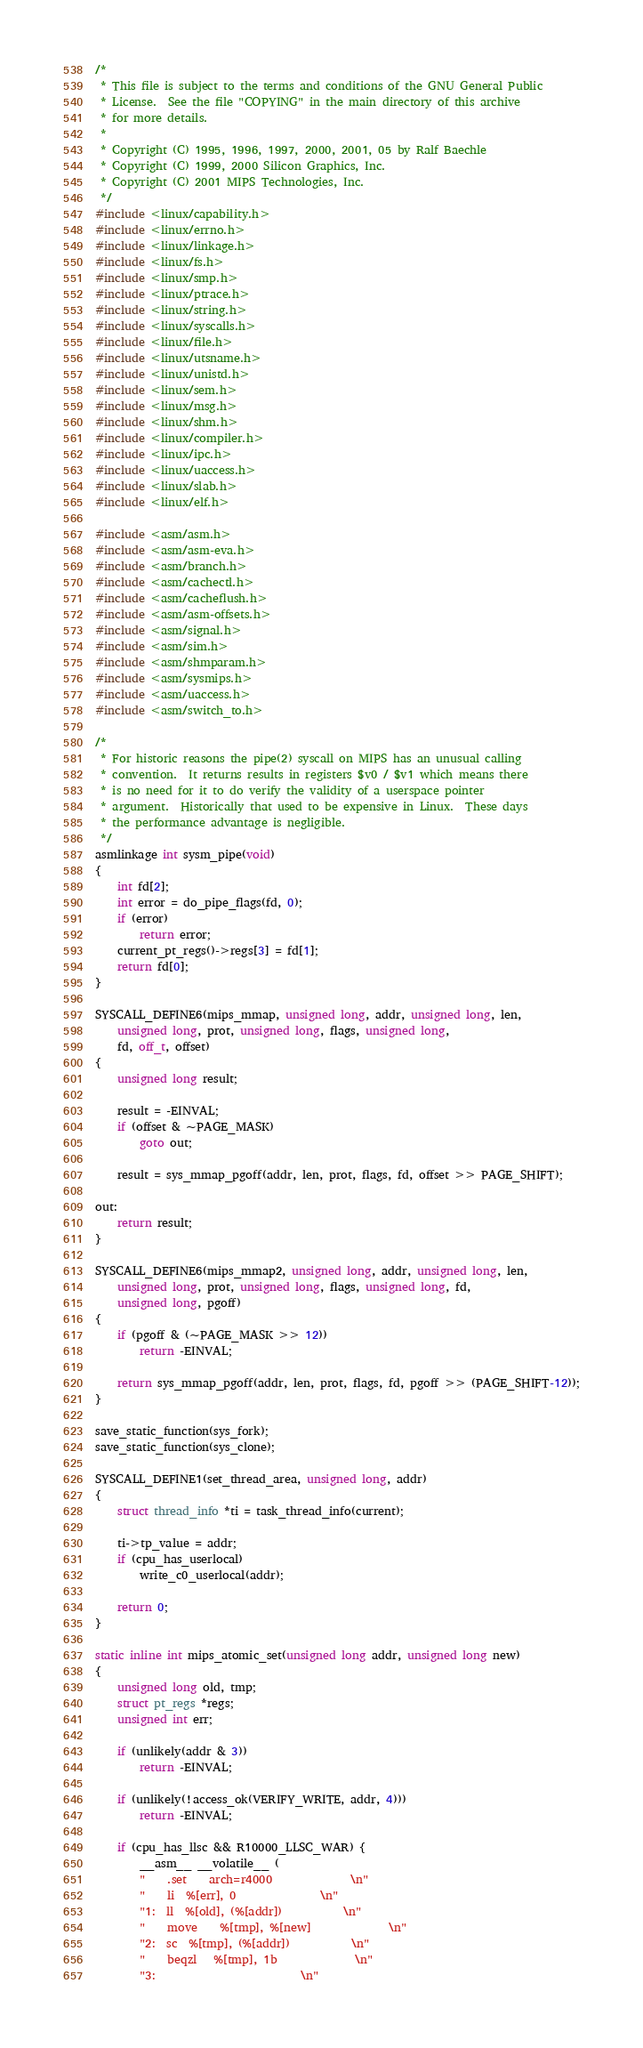<code> <loc_0><loc_0><loc_500><loc_500><_C_>/*
 * This file is subject to the terms and conditions of the GNU General Public
 * License.  See the file "COPYING" in the main directory of this archive
 * for more details.
 *
 * Copyright (C) 1995, 1996, 1997, 2000, 2001, 05 by Ralf Baechle
 * Copyright (C) 1999, 2000 Silicon Graphics, Inc.
 * Copyright (C) 2001 MIPS Technologies, Inc.
 */
#include <linux/capability.h>
#include <linux/errno.h>
#include <linux/linkage.h>
#include <linux/fs.h>
#include <linux/smp.h>
#include <linux/ptrace.h>
#include <linux/string.h>
#include <linux/syscalls.h>
#include <linux/file.h>
#include <linux/utsname.h>
#include <linux/unistd.h>
#include <linux/sem.h>
#include <linux/msg.h>
#include <linux/shm.h>
#include <linux/compiler.h>
#include <linux/ipc.h>
#include <linux/uaccess.h>
#include <linux/slab.h>
#include <linux/elf.h>

#include <asm/asm.h>
#include <asm/asm-eva.h>
#include <asm/branch.h>
#include <asm/cachectl.h>
#include <asm/cacheflush.h>
#include <asm/asm-offsets.h>
#include <asm/signal.h>
#include <asm/sim.h>
#include <asm/shmparam.h>
#include <asm/sysmips.h>
#include <asm/uaccess.h>
#include <asm/switch_to.h>

/*
 * For historic reasons the pipe(2) syscall on MIPS has an unusual calling
 * convention.	It returns results in registers $v0 / $v1 which means there
 * is no need for it to do verify the validity of a userspace pointer
 * argument.  Historically that used to be expensive in Linux.	These days
 * the performance advantage is negligible.
 */
asmlinkage int sysm_pipe(void)
{
	int fd[2];
	int error = do_pipe_flags(fd, 0);
	if (error)
		return error;
	current_pt_regs()->regs[3] = fd[1];
	return fd[0];
}

SYSCALL_DEFINE6(mips_mmap, unsigned long, addr, unsigned long, len,
	unsigned long, prot, unsigned long, flags, unsigned long,
	fd, off_t, offset)
{
	unsigned long result;

	result = -EINVAL;
	if (offset & ~PAGE_MASK)
		goto out;

	result = sys_mmap_pgoff(addr, len, prot, flags, fd, offset >> PAGE_SHIFT);

out:
	return result;
}

SYSCALL_DEFINE6(mips_mmap2, unsigned long, addr, unsigned long, len,
	unsigned long, prot, unsigned long, flags, unsigned long, fd,
	unsigned long, pgoff)
{
	if (pgoff & (~PAGE_MASK >> 12))
		return -EINVAL;

	return sys_mmap_pgoff(addr, len, prot, flags, fd, pgoff >> (PAGE_SHIFT-12));
}

save_static_function(sys_fork);
save_static_function(sys_clone);

SYSCALL_DEFINE1(set_thread_area, unsigned long, addr)
{
	struct thread_info *ti = task_thread_info(current);

	ti->tp_value = addr;
	if (cpu_has_userlocal)
		write_c0_userlocal(addr);

	return 0;
}

static inline int mips_atomic_set(unsigned long addr, unsigned long new)
{
	unsigned long old, tmp;
	struct pt_regs *regs;
	unsigned int err;

	if (unlikely(addr & 3))
		return -EINVAL;

	if (unlikely(!access_ok(VERIFY_WRITE, addr, 4)))
		return -EINVAL;

	if (cpu_has_llsc && R10000_LLSC_WAR) {
		__asm__ __volatile__ (
		"	.set	arch=r4000				\n"
		"	li	%[err], 0				\n"
		"1:	ll	%[old], (%[addr])			\n"
		"	move	%[tmp], %[new]				\n"
		"2:	sc	%[tmp], (%[addr])			\n"
		"	beqzl	%[tmp], 1b				\n"
		"3:							\n"</code> 